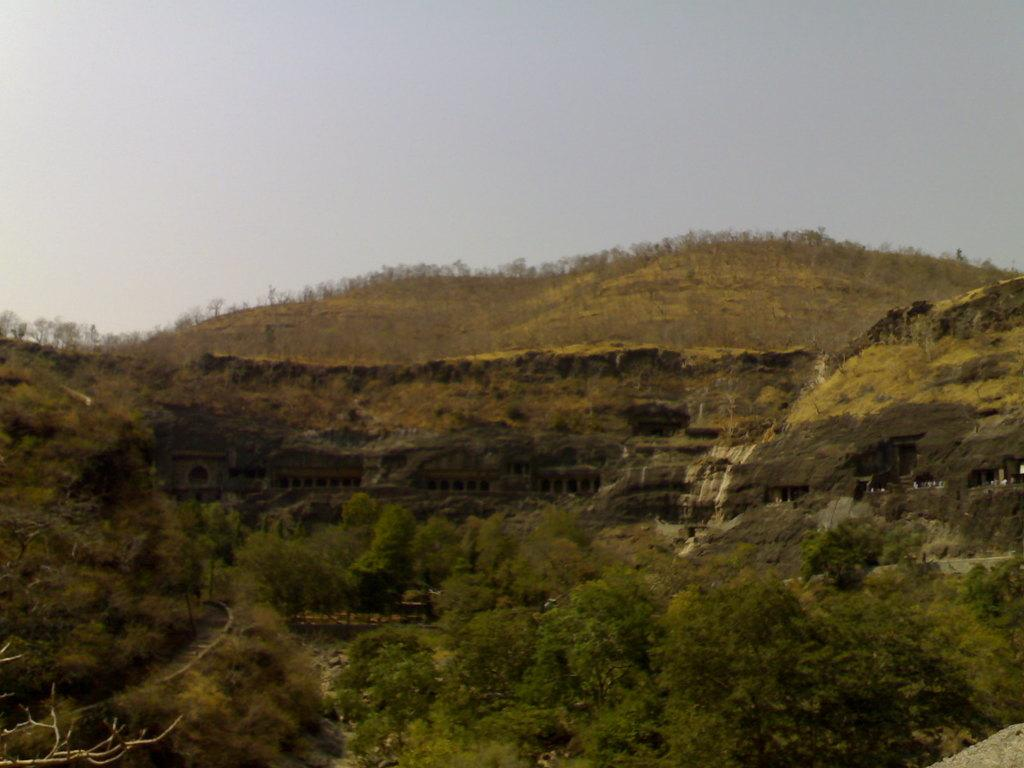What type of structure is present in the image? There is a building in the image. What other natural elements can be seen in the image? There is a group of trees and hills visible in the image. What is visible in the background of the image? The sky is visible in the image. How would you describe the sky in the image? The sky appears cloudy in the image. How are the plants being sorted in the image? There are no plants present in the image, so they cannot be sorted. Can you see any chickens in the image? There are no chickens present in the image. 